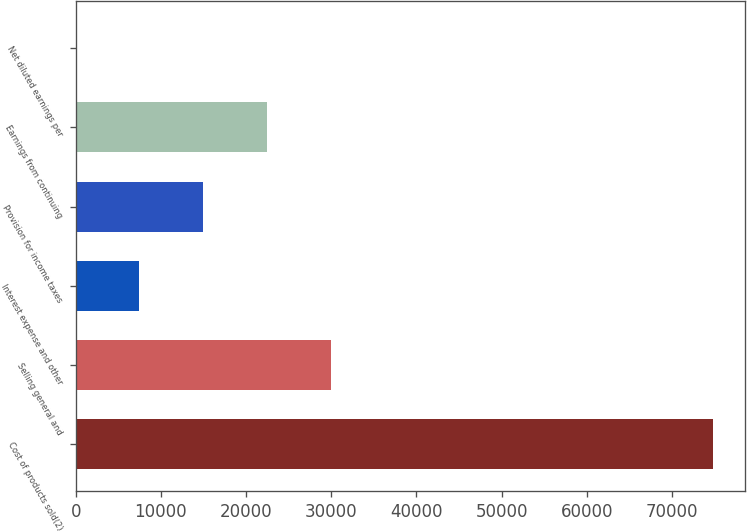<chart> <loc_0><loc_0><loc_500><loc_500><bar_chart><fcel>Cost of products sold(2)<fcel>Selling general and<fcel>Interest expense and other<fcel>Provision for income taxes<fcel>Earnings from continuing<fcel>Net diluted earnings per<nl><fcel>74850.2<fcel>29941.5<fcel>7487.12<fcel>14971.9<fcel>22456.7<fcel>2.33<nl></chart> 